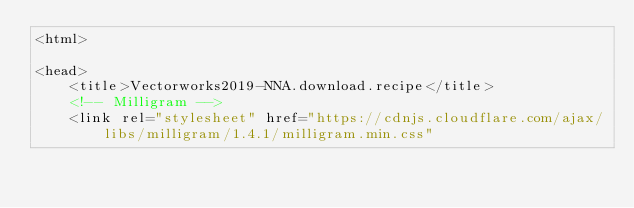Convert code to text. <code><loc_0><loc_0><loc_500><loc_500><_HTML_><html>

<head>
    <title>Vectorworks2019-NNA.download.recipe</title>
    <!-- Milligram -->
    <link rel="stylesheet" href="https://cdnjs.cloudflare.com/ajax/libs/milligram/1.4.1/milligram.min.css"</code> 